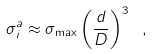Convert formula to latex. <formula><loc_0><loc_0><loc_500><loc_500>\sigma _ { i } ^ { a } \approx \sigma _ { \max } \left ( \frac { d } { D } \right ) ^ { 3 } \ ,</formula> 